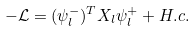<formula> <loc_0><loc_0><loc_500><loc_500>- \mathcal { L } = ( \psi ^ { - } _ { l } ) ^ { T } X _ { l } \psi ^ { + } _ { l } + H . c .</formula> 